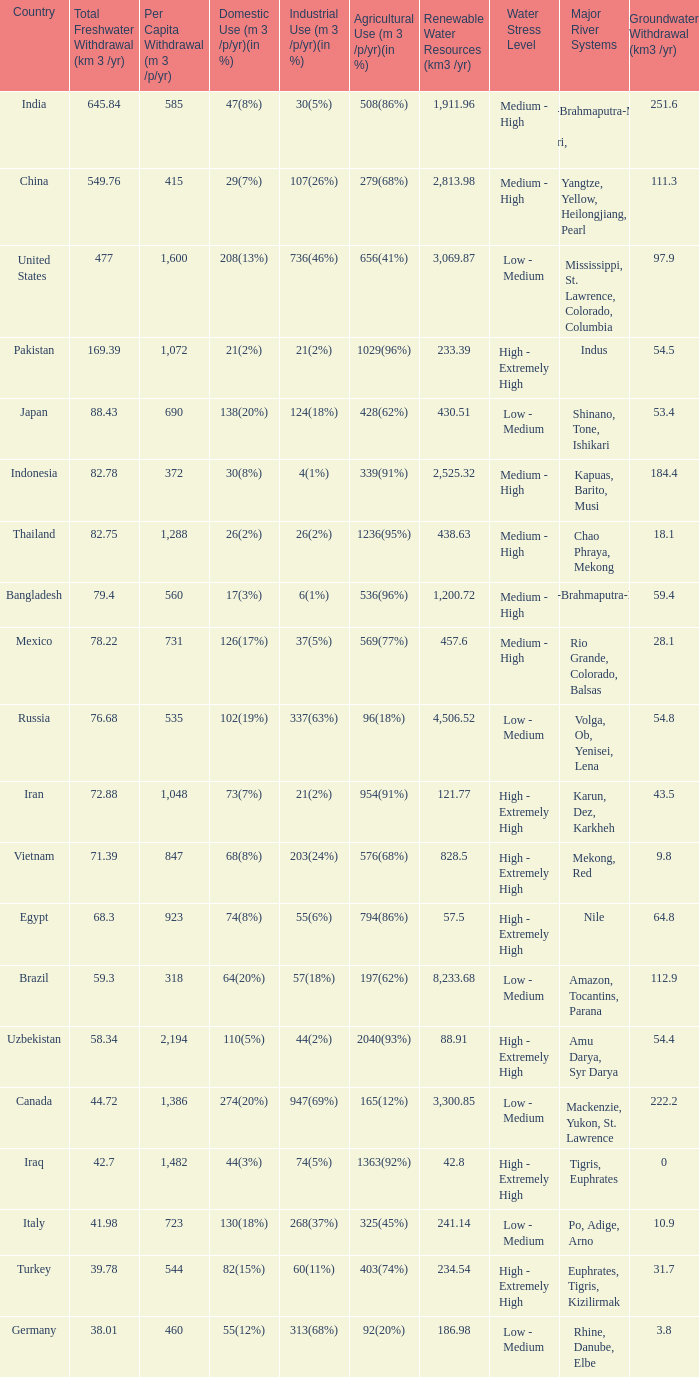What is the average Total Freshwater Withdrawal (km 3 /yr), when Industrial Use (m 3 /p/yr)(in %) is 337(63%), and when Per Capita Withdrawal (m 3 /p/yr) is greater than 535? None. 